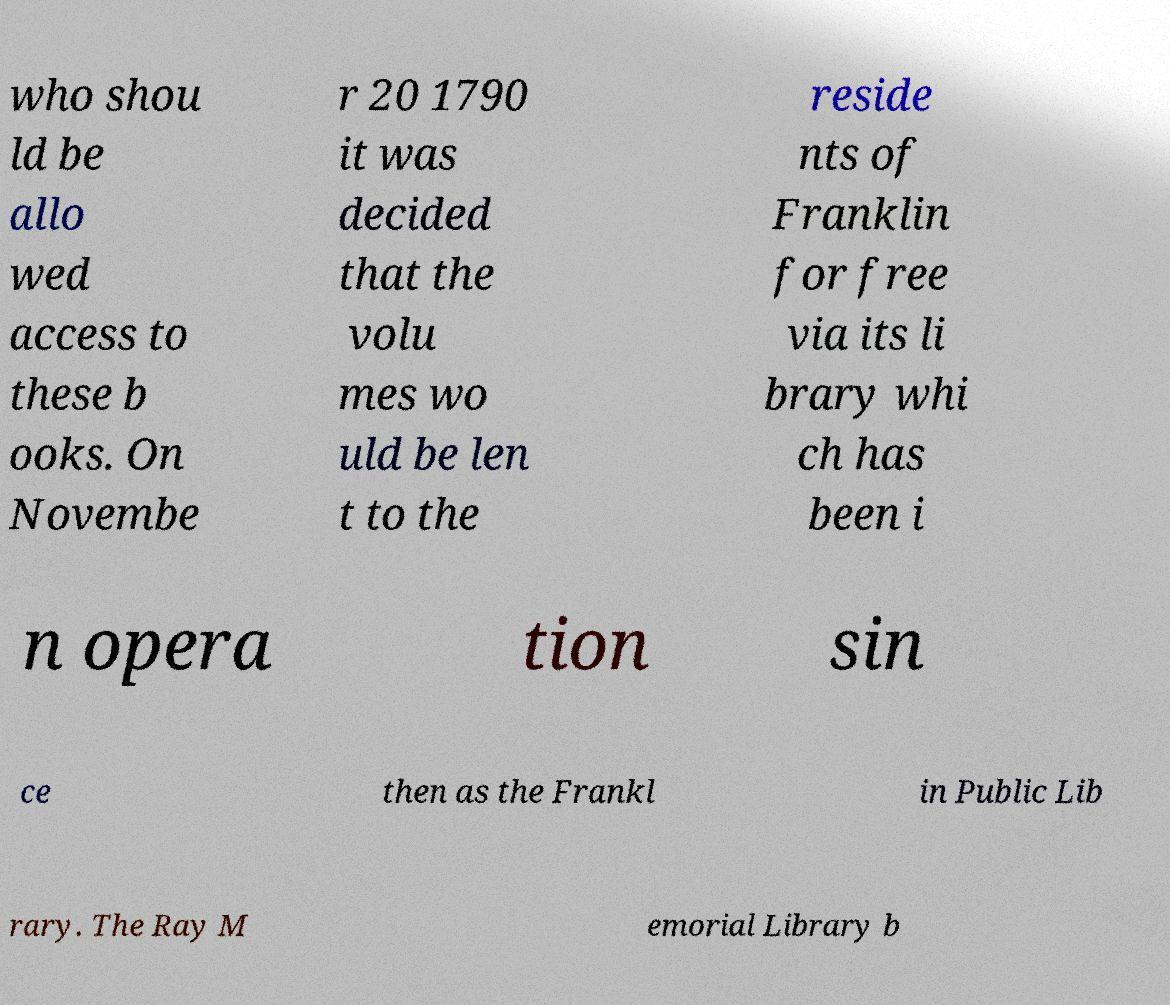Could you assist in decoding the text presented in this image and type it out clearly? who shou ld be allo wed access to these b ooks. On Novembe r 20 1790 it was decided that the volu mes wo uld be len t to the reside nts of Franklin for free via its li brary whi ch has been i n opera tion sin ce then as the Frankl in Public Lib rary. The Ray M emorial Library b 